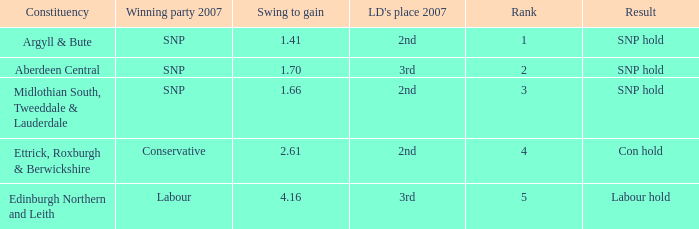How many times is the constituency edinburgh northern and leith? 1.0. 